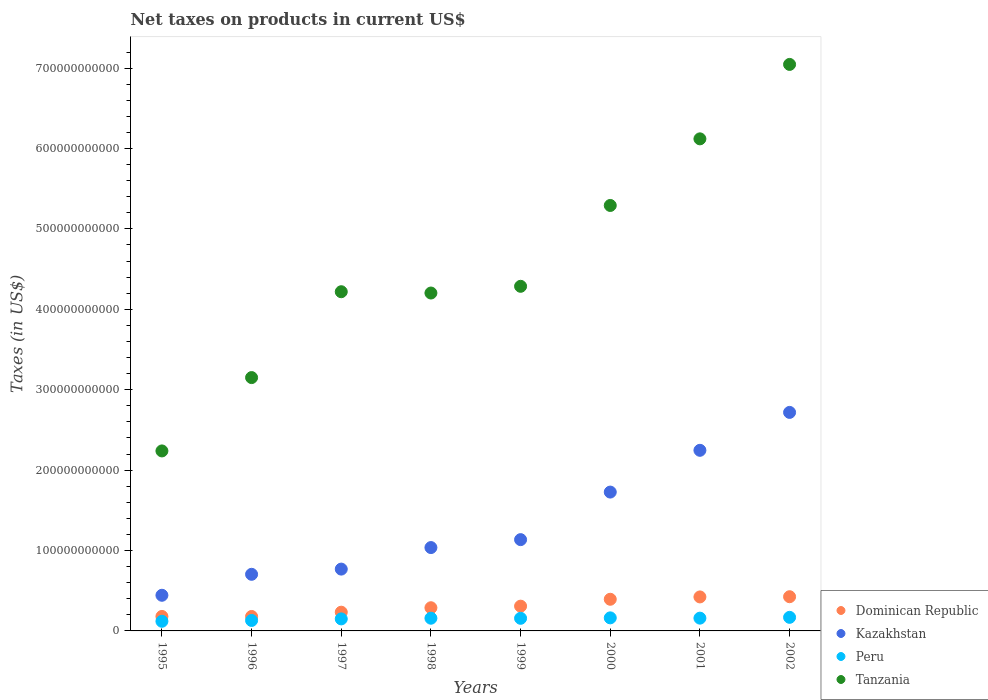Is the number of dotlines equal to the number of legend labels?
Ensure brevity in your answer.  Yes. What is the net taxes on products in Peru in 1995?
Offer a very short reply. 1.20e+1. Across all years, what is the maximum net taxes on products in Kazakhstan?
Your response must be concise. 2.72e+11. Across all years, what is the minimum net taxes on products in Tanzania?
Your response must be concise. 2.24e+11. In which year was the net taxes on products in Dominican Republic minimum?
Offer a very short reply. 1996. What is the total net taxes on products in Peru in the graph?
Offer a terse response. 1.20e+11. What is the difference between the net taxes on products in Peru in 1996 and that in 1999?
Your response must be concise. -2.68e+09. What is the difference between the net taxes on products in Peru in 1998 and the net taxes on products in Kazakhstan in 1996?
Make the answer very short. -5.46e+1. What is the average net taxes on products in Kazakhstan per year?
Your response must be concise. 1.35e+11. In the year 2002, what is the difference between the net taxes on products in Peru and net taxes on products in Dominican Republic?
Ensure brevity in your answer.  -2.57e+1. In how many years, is the net taxes on products in Peru greater than 40000000000 US$?
Offer a very short reply. 0. What is the ratio of the net taxes on products in Dominican Republic in 1995 to that in 1997?
Give a very brief answer. 0.77. What is the difference between the highest and the second highest net taxes on products in Peru?
Keep it short and to the point. 6.46e+08. What is the difference between the highest and the lowest net taxes on products in Tanzania?
Your response must be concise. 4.81e+11. Is the sum of the net taxes on products in Tanzania in 1997 and 1999 greater than the maximum net taxes on products in Kazakhstan across all years?
Keep it short and to the point. Yes. What is the difference between two consecutive major ticks on the Y-axis?
Provide a succinct answer. 1.00e+11. Does the graph contain any zero values?
Your answer should be compact. No. Does the graph contain grids?
Provide a succinct answer. No. Where does the legend appear in the graph?
Your answer should be very brief. Bottom right. How are the legend labels stacked?
Give a very brief answer. Vertical. What is the title of the graph?
Keep it short and to the point. Net taxes on products in current US$. What is the label or title of the X-axis?
Offer a very short reply. Years. What is the label or title of the Y-axis?
Offer a very short reply. Taxes (in US$). What is the Taxes (in US$) in Dominican Republic in 1995?
Give a very brief answer. 1.80e+1. What is the Taxes (in US$) of Kazakhstan in 1995?
Your answer should be very brief. 4.43e+1. What is the Taxes (in US$) of Peru in 1995?
Offer a very short reply. 1.20e+1. What is the Taxes (in US$) in Tanzania in 1995?
Offer a very short reply. 2.24e+11. What is the Taxes (in US$) of Dominican Republic in 1996?
Offer a terse response. 1.80e+1. What is the Taxes (in US$) in Kazakhstan in 1996?
Provide a succinct answer. 7.04e+1. What is the Taxes (in US$) of Peru in 1996?
Provide a succinct answer. 1.30e+1. What is the Taxes (in US$) in Tanzania in 1996?
Provide a succinct answer. 3.15e+11. What is the Taxes (in US$) of Dominican Republic in 1997?
Your answer should be very brief. 2.33e+1. What is the Taxes (in US$) in Kazakhstan in 1997?
Your answer should be compact. 7.69e+1. What is the Taxes (in US$) in Peru in 1997?
Your answer should be very brief. 1.50e+1. What is the Taxes (in US$) in Tanzania in 1997?
Offer a very short reply. 4.22e+11. What is the Taxes (in US$) of Dominican Republic in 1998?
Your answer should be compact. 2.88e+1. What is the Taxes (in US$) in Kazakhstan in 1998?
Make the answer very short. 1.04e+11. What is the Taxes (in US$) of Peru in 1998?
Give a very brief answer. 1.58e+1. What is the Taxes (in US$) in Tanzania in 1998?
Ensure brevity in your answer.  4.20e+11. What is the Taxes (in US$) in Dominican Republic in 1999?
Keep it short and to the point. 3.08e+1. What is the Taxes (in US$) of Kazakhstan in 1999?
Offer a terse response. 1.14e+11. What is the Taxes (in US$) of Peru in 1999?
Provide a succinct answer. 1.57e+1. What is the Taxes (in US$) in Tanzania in 1999?
Your answer should be very brief. 4.29e+11. What is the Taxes (in US$) of Dominican Republic in 2000?
Keep it short and to the point. 3.94e+1. What is the Taxes (in US$) of Kazakhstan in 2000?
Give a very brief answer. 1.73e+11. What is the Taxes (in US$) in Peru in 2000?
Give a very brief answer. 1.62e+1. What is the Taxes (in US$) in Tanzania in 2000?
Ensure brevity in your answer.  5.29e+11. What is the Taxes (in US$) of Dominican Republic in 2001?
Keep it short and to the point. 4.23e+1. What is the Taxes (in US$) of Kazakhstan in 2001?
Keep it short and to the point. 2.25e+11. What is the Taxes (in US$) in Peru in 2001?
Offer a terse response. 1.59e+1. What is the Taxes (in US$) in Tanzania in 2001?
Your answer should be compact. 6.12e+11. What is the Taxes (in US$) of Dominican Republic in 2002?
Offer a very short reply. 4.25e+1. What is the Taxes (in US$) in Kazakhstan in 2002?
Offer a very short reply. 2.72e+11. What is the Taxes (in US$) in Peru in 2002?
Give a very brief answer. 1.69e+1. What is the Taxes (in US$) of Tanzania in 2002?
Keep it short and to the point. 7.05e+11. Across all years, what is the maximum Taxes (in US$) of Dominican Republic?
Keep it short and to the point. 4.25e+1. Across all years, what is the maximum Taxes (in US$) of Kazakhstan?
Provide a succinct answer. 2.72e+11. Across all years, what is the maximum Taxes (in US$) of Peru?
Your answer should be very brief. 1.69e+1. Across all years, what is the maximum Taxes (in US$) in Tanzania?
Ensure brevity in your answer.  7.05e+11. Across all years, what is the minimum Taxes (in US$) of Dominican Republic?
Provide a succinct answer. 1.80e+1. Across all years, what is the minimum Taxes (in US$) of Kazakhstan?
Make the answer very short. 4.43e+1. Across all years, what is the minimum Taxes (in US$) of Peru?
Your response must be concise. 1.20e+1. Across all years, what is the minimum Taxes (in US$) of Tanzania?
Your answer should be compact. 2.24e+11. What is the total Taxes (in US$) of Dominican Republic in the graph?
Offer a terse response. 2.43e+11. What is the total Taxes (in US$) of Kazakhstan in the graph?
Your answer should be very brief. 1.08e+12. What is the total Taxes (in US$) of Peru in the graph?
Keep it short and to the point. 1.20e+11. What is the total Taxes (in US$) in Tanzania in the graph?
Your answer should be compact. 3.66e+12. What is the difference between the Taxes (in US$) of Dominican Republic in 1995 and that in 1996?
Keep it short and to the point. 4.87e+07. What is the difference between the Taxes (in US$) of Kazakhstan in 1995 and that in 1996?
Ensure brevity in your answer.  -2.61e+1. What is the difference between the Taxes (in US$) of Peru in 1995 and that in 1996?
Make the answer very short. -1.02e+09. What is the difference between the Taxes (in US$) of Tanzania in 1995 and that in 1996?
Keep it short and to the point. -9.12e+1. What is the difference between the Taxes (in US$) in Dominican Republic in 1995 and that in 1997?
Ensure brevity in your answer.  -5.27e+09. What is the difference between the Taxes (in US$) in Kazakhstan in 1995 and that in 1997?
Your response must be concise. -3.26e+1. What is the difference between the Taxes (in US$) in Peru in 1995 and that in 1997?
Your answer should be compact. -2.96e+09. What is the difference between the Taxes (in US$) of Tanzania in 1995 and that in 1997?
Provide a short and direct response. -1.98e+11. What is the difference between the Taxes (in US$) in Dominican Republic in 1995 and that in 1998?
Your answer should be compact. -1.08e+1. What is the difference between the Taxes (in US$) in Kazakhstan in 1995 and that in 1998?
Ensure brevity in your answer.  -5.93e+1. What is the difference between the Taxes (in US$) in Peru in 1995 and that in 1998?
Ensure brevity in your answer.  -3.80e+09. What is the difference between the Taxes (in US$) in Tanzania in 1995 and that in 1998?
Your answer should be very brief. -1.96e+11. What is the difference between the Taxes (in US$) of Dominican Republic in 1995 and that in 1999?
Keep it short and to the point. -1.28e+1. What is the difference between the Taxes (in US$) in Kazakhstan in 1995 and that in 1999?
Provide a short and direct response. -6.92e+1. What is the difference between the Taxes (in US$) in Peru in 1995 and that in 1999?
Give a very brief answer. -3.70e+09. What is the difference between the Taxes (in US$) of Tanzania in 1995 and that in 1999?
Your answer should be very brief. -2.05e+11. What is the difference between the Taxes (in US$) of Dominican Republic in 1995 and that in 2000?
Provide a short and direct response. -2.14e+1. What is the difference between the Taxes (in US$) of Kazakhstan in 1995 and that in 2000?
Make the answer very short. -1.28e+11. What is the difference between the Taxes (in US$) of Peru in 1995 and that in 2000?
Your answer should be compact. -4.25e+09. What is the difference between the Taxes (in US$) of Tanzania in 1995 and that in 2000?
Your answer should be compact. -3.05e+11. What is the difference between the Taxes (in US$) in Dominican Republic in 1995 and that in 2001?
Offer a terse response. -2.43e+1. What is the difference between the Taxes (in US$) of Kazakhstan in 1995 and that in 2001?
Your answer should be very brief. -1.80e+11. What is the difference between the Taxes (in US$) of Peru in 1995 and that in 2001?
Make the answer very short. -3.89e+09. What is the difference between the Taxes (in US$) of Tanzania in 1995 and that in 2001?
Offer a terse response. -3.88e+11. What is the difference between the Taxes (in US$) in Dominican Republic in 1995 and that in 2002?
Your answer should be very brief. -2.45e+1. What is the difference between the Taxes (in US$) in Kazakhstan in 1995 and that in 2002?
Ensure brevity in your answer.  -2.27e+11. What is the difference between the Taxes (in US$) of Peru in 1995 and that in 2002?
Offer a terse response. -4.89e+09. What is the difference between the Taxes (in US$) of Tanzania in 1995 and that in 2002?
Your answer should be compact. -4.81e+11. What is the difference between the Taxes (in US$) in Dominican Republic in 1996 and that in 1997?
Your answer should be compact. -5.32e+09. What is the difference between the Taxes (in US$) of Kazakhstan in 1996 and that in 1997?
Provide a succinct answer. -6.48e+09. What is the difference between the Taxes (in US$) of Peru in 1996 and that in 1997?
Your response must be concise. -1.94e+09. What is the difference between the Taxes (in US$) in Tanzania in 1996 and that in 1997?
Offer a terse response. -1.07e+11. What is the difference between the Taxes (in US$) of Dominican Republic in 1996 and that in 1998?
Your response must be concise. -1.09e+1. What is the difference between the Taxes (in US$) of Kazakhstan in 1996 and that in 1998?
Offer a terse response. -3.33e+1. What is the difference between the Taxes (in US$) in Peru in 1996 and that in 1998?
Your answer should be compact. -2.78e+09. What is the difference between the Taxes (in US$) in Tanzania in 1996 and that in 1998?
Your answer should be very brief. -1.05e+11. What is the difference between the Taxes (in US$) in Dominican Republic in 1996 and that in 1999?
Keep it short and to the point. -1.28e+1. What is the difference between the Taxes (in US$) of Kazakhstan in 1996 and that in 1999?
Offer a terse response. -4.31e+1. What is the difference between the Taxes (in US$) of Peru in 1996 and that in 1999?
Give a very brief answer. -2.68e+09. What is the difference between the Taxes (in US$) in Tanzania in 1996 and that in 1999?
Your response must be concise. -1.14e+11. What is the difference between the Taxes (in US$) in Dominican Republic in 1996 and that in 2000?
Make the answer very short. -2.14e+1. What is the difference between the Taxes (in US$) in Kazakhstan in 1996 and that in 2000?
Make the answer very short. -1.02e+11. What is the difference between the Taxes (in US$) in Peru in 1996 and that in 2000?
Ensure brevity in your answer.  -3.23e+09. What is the difference between the Taxes (in US$) in Tanzania in 1996 and that in 2000?
Provide a short and direct response. -2.14e+11. What is the difference between the Taxes (in US$) of Dominican Republic in 1996 and that in 2001?
Offer a terse response. -2.43e+1. What is the difference between the Taxes (in US$) of Kazakhstan in 1996 and that in 2001?
Provide a succinct answer. -1.54e+11. What is the difference between the Taxes (in US$) in Peru in 1996 and that in 2001?
Your answer should be compact. -2.87e+09. What is the difference between the Taxes (in US$) in Tanzania in 1996 and that in 2001?
Offer a terse response. -2.97e+11. What is the difference between the Taxes (in US$) in Dominican Republic in 1996 and that in 2002?
Ensure brevity in your answer.  -2.46e+1. What is the difference between the Taxes (in US$) of Kazakhstan in 1996 and that in 2002?
Make the answer very short. -2.01e+11. What is the difference between the Taxes (in US$) in Peru in 1996 and that in 2002?
Offer a terse response. -3.87e+09. What is the difference between the Taxes (in US$) in Tanzania in 1996 and that in 2002?
Keep it short and to the point. -3.89e+11. What is the difference between the Taxes (in US$) in Dominican Republic in 1997 and that in 1998?
Keep it short and to the point. -5.54e+09. What is the difference between the Taxes (in US$) of Kazakhstan in 1997 and that in 1998?
Your answer should be compact. -2.68e+1. What is the difference between the Taxes (in US$) of Peru in 1997 and that in 1998?
Your answer should be very brief. -8.38e+08. What is the difference between the Taxes (in US$) of Tanzania in 1997 and that in 1998?
Give a very brief answer. 1.62e+09. What is the difference between the Taxes (in US$) in Dominican Republic in 1997 and that in 1999?
Your answer should be compact. -7.51e+09. What is the difference between the Taxes (in US$) in Kazakhstan in 1997 and that in 1999?
Your answer should be very brief. -3.66e+1. What is the difference between the Taxes (in US$) in Peru in 1997 and that in 1999?
Your answer should be compact. -7.37e+08. What is the difference between the Taxes (in US$) in Tanzania in 1997 and that in 1999?
Provide a short and direct response. -6.75e+09. What is the difference between the Taxes (in US$) of Dominican Republic in 1997 and that in 2000?
Offer a terse response. -1.61e+1. What is the difference between the Taxes (in US$) in Kazakhstan in 1997 and that in 2000?
Your response must be concise. -9.58e+1. What is the difference between the Taxes (in US$) of Peru in 1997 and that in 2000?
Make the answer very short. -1.28e+09. What is the difference between the Taxes (in US$) of Tanzania in 1997 and that in 2000?
Ensure brevity in your answer.  -1.07e+11. What is the difference between the Taxes (in US$) of Dominican Republic in 1997 and that in 2001?
Keep it short and to the point. -1.90e+1. What is the difference between the Taxes (in US$) in Kazakhstan in 1997 and that in 2001?
Offer a terse response. -1.48e+11. What is the difference between the Taxes (in US$) of Peru in 1997 and that in 2001?
Keep it short and to the point. -9.29e+08. What is the difference between the Taxes (in US$) of Tanzania in 1997 and that in 2001?
Keep it short and to the point. -1.90e+11. What is the difference between the Taxes (in US$) in Dominican Republic in 1997 and that in 2002?
Make the answer very short. -1.93e+1. What is the difference between the Taxes (in US$) in Kazakhstan in 1997 and that in 2002?
Your response must be concise. -1.95e+11. What is the difference between the Taxes (in US$) in Peru in 1997 and that in 2002?
Make the answer very short. -1.93e+09. What is the difference between the Taxes (in US$) of Tanzania in 1997 and that in 2002?
Your answer should be very brief. -2.83e+11. What is the difference between the Taxes (in US$) of Dominican Republic in 1998 and that in 1999?
Offer a terse response. -1.97e+09. What is the difference between the Taxes (in US$) of Kazakhstan in 1998 and that in 1999?
Your response must be concise. -9.86e+09. What is the difference between the Taxes (in US$) in Peru in 1998 and that in 1999?
Give a very brief answer. 1.01e+08. What is the difference between the Taxes (in US$) in Tanzania in 1998 and that in 1999?
Provide a short and direct response. -8.36e+09. What is the difference between the Taxes (in US$) in Dominican Republic in 1998 and that in 2000?
Your response must be concise. -1.05e+1. What is the difference between the Taxes (in US$) of Kazakhstan in 1998 and that in 2000?
Keep it short and to the point. -6.90e+1. What is the difference between the Taxes (in US$) of Peru in 1998 and that in 2000?
Your response must be concise. -4.46e+08. What is the difference between the Taxes (in US$) of Tanzania in 1998 and that in 2000?
Provide a succinct answer. -1.09e+11. What is the difference between the Taxes (in US$) in Dominican Republic in 1998 and that in 2001?
Ensure brevity in your answer.  -1.35e+1. What is the difference between the Taxes (in US$) in Kazakhstan in 1998 and that in 2001?
Your answer should be compact. -1.21e+11. What is the difference between the Taxes (in US$) in Peru in 1998 and that in 2001?
Make the answer very short. -9.18e+07. What is the difference between the Taxes (in US$) in Tanzania in 1998 and that in 2001?
Give a very brief answer. -1.92e+11. What is the difference between the Taxes (in US$) of Dominican Republic in 1998 and that in 2002?
Your response must be concise. -1.37e+1. What is the difference between the Taxes (in US$) of Kazakhstan in 1998 and that in 2002?
Your answer should be compact. -1.68e+11. What is the difference between the Taxes (in US$) of Peru in 1998 and that in 2002?
Give a very brief answer. -1.09e+09. What is the difference between the Taxes (in US$) of Tanzania in 1998 and that in 2002?
Keep it short and to the point. -2.84e+11. What is the difference between the Taxes (in US$) of Dominican Republic in 1999 and that in 2000?
Your response must be concise. -8.57e+09. What is the difference between the Taxes (in US$) of Kazakhstan in 1999 and that in 2000?
Your response must be concise. -5.92e+1. What is the difference between the Taxes (in US$) of Peru in 1999 and that in 2000?
Give a very brief answer. -5.47e+08. What is the difference between the Taxes (in US$) in Tanzania in 1999 and that in 2000?
Provide a short and direct response. -1.01e+11. What is the difference between the Taxes (in US$) in Dominican Republic in 1999 and that in 2001?
Your answer should be compact. -1.15e+1. What is the difference between the Taxes (in US$) in Kazakhstan in 1999 and that in 2001?
Provide a succinct answer. -1.11e+11. What is the difference between the Taxes (in US$) of Peru in 1999 and that in 2001?
Offer a very short reply. -1.93e+08. What is the difference between the Taxes (in US$) of Tanzania in 1999 and that in 2001?
Keep it short and to the point. -1.83e+11. What is the difference between the Taxes (in US$) of Dominican Republic in 1999 and that in 2002?
Give a very brief answer. -1.17e+1. What is the difference between the Taxes (in US$) of Kazakhstan in 1999 and that in 2002?
Ensure brevity in your answer.  -1.58e+11. What is the difference between the Taxes (in US$) in Peru in 1999 and that in 2002?
Ensure brevity in your answer.  -1.19e+09. What is the difference between the Taxes (in US$) of Tanzania in 1999 and that in 2002?
Your response must be concise. -2.76e+11. What is the difference between the Taxes (in US$) in Dominican Republic in 2000 and that in 2001?
Your response must be concise. -2.92e+09. What is the difference between the Taxes (in US$) of Kazakhstan in 2000 and that in 2001?
Give a very brief answer. -5.19e+1. What is the difference between the Taxes (in US$) of Peru in 2000 and that in 2001?
Your answer should be compact. 3.54e+08. What is the difference between the Taxes (in US$) of Tanzania in 2000 and that in 2001?
Provide a short and direct response. -8.28e+1. What is the difference between the Taxes (in US$) of Dominican Republic in 2000 and that in 2002?
Your response must be concise. -3.17e+09. What is the difference between the Taxes (in US$) in Kazakhstan in 2000 and that in 2002?
Keep it short and to the point. -9.91e+1. What is the difference between the Taxes (in US$) in Peru in 2000 and that in 2002?
Your response must be concise. -6.46e+08. What is the difference between the Taxes (in US$) of Tanzania in 2000 and that in 2002?
Keep it short and to the point. -1.75e+11. What is the difference between the Taxes (in US$) of Dominican Republic in 2001 and that in 2002?
Make the answer very short. -2.54e+08. What is the difference between the Taxes (in US$) of Kazakhstan in 2001 and that in 2002?
Your response must be concise. -4.72e+1. What is the difference between the Taxes (in US$) of Peru in 2001 and that in 2002?
Make the answer very short. -1.00e+09. What is the difference between the Taxes (in US$) in Tanzania in 2001 and that in 2002?
Keep it short and to the point. -9.26e+1. What is the difference between the Taxes (in US$) of Dominican Republic in 1995 and the Taxes (in US$) of Kazakhstan in 1996?
Provide a short and direct response. -5.24e+1. What is the difference between the Taxes (in US$) of Dominican Republic in 1995 and the Taxes (in US$) of Peru in 1996?
Provide a succinct answer. 5.00e+09. What is the difference between the Taxes (in US$) of Dominican Republic in 1995 and the Taxes (in US$) of Tanzania in 1996?
Give a very brief answer. -2.97e+11. What is the difference between the Taxes (in US$) in Kazakhstan in 1995 and the Taxes (in US$) in Peru in 1996?
Provide a short and direct response. 3.13e+1. What is the difference between the Taxes (in US$) in Kazakhstan in 1995 and the Taxes (in US$) in Tanzania in 1996?
Keep it short and to the point. -2.71e+11. What is the difference between the Taxes (in US$) of Peru in 1995 and the Taxes (in US$) of Tanzania in 1996?
Provide a short and direct response. -3.03e+11. What is the difference between the Taxes (in US$) of Dominican Republic in 1995 and the Taxes (in US$) of Kazakhstan in 1997?
Provide a short and direct response. -5.89e+1. What is the difference between the Taxes (in US$) of Dominican Republic in 1995 and the Taxes (in US$) of Peru in 1997?
Your response must be concise. 3.06e+09. What is the difference between the Taxes (in US$) in Dominican Republic in 1995 and the Taxes (in US$) in Tanzania in 1997?
Give a very brief answer. -4.04e+11. What is the difference between the Taxes (in US$) in Kazakhstan in 1995 and the Taxes (in US$) in Peru in 1997?
Provide a succinct answer. 2.94e+1. What is the difference between the Taxes (in US$) in Kazakhstan in 1995 and the Taxes (in US$) in Tanzania in 1997?
Your response must be concise. -3.78e+11. What is the difference between the Taxes (in US$) in Peru in 1995 and the Taxes (in US$) in Tanzania in 1997?
Keep it short and to the point. -4.10e+11. What is the difference between the Taxes (in US$) of Dominican Republic in 1995 and the Taxes (in US$) of Kazakhstan in 1998?
Offer a very short reply. -8.57e+1. What is the difference between the Taxes (in US$) in Dominican Republic in 1995 and the Taxes (in US$) in Peru in 1998?
Offer a terse response. 2.22e+09. What is the difference between the Taxes (in US$) in Dominican Republic in 1995 and the Taxes (in US$) in Tanzania in 1998?
Your answer should be compact. -4.02e+11. What is the difference between the Taxes (in US$) of Kazakhstan in 1995 and the Taxes (in US$) of Peru in 1998?
Make the answer very short. 2.85e+1. What is the difference between the Taxes (in US$) of Kazakhstan in 1995 and the Taxes (in US$) of Tanzania in 1998?
Give a very brief answer. -3.76e+11. What is the difference between the Taxes (in US$) in Peru in 1995 and the Taxes (in US$) in Tanzania in 1998?
Provide a short and direct response. -4.08e+11. What is the difference between the Taxes (in US$) in Dominican Republic in 1995 and the Taxes (in US$) in Kazakhstan in 1999?
Give a very brief answer. -9.55e+1. What is the difference between the Taxes (in US$) in Dominican Republic in 1995 and the Taxes (in US$) in Peru in 1999?
Your answer should be compact. 2.32e+09. What is the difference between the Taxes (in US$) of Dominican Republic in 1995 and the Taxes (in US$) of Tanzania in 1999?
Make the answer very short. -4.11e+11. What is the difference between the Taxes (in US$) in Kazakhstan in 1995 and the Taxes (in US$) in Peru in 1999?
Make the answer very short. 2.86e+1. What is the difference between the Taxes (in US$) in Kazakhstan in 1995 and the Taxes (in US$) in Tanzania in 1999?
Give a very brief answer. -3.84e+11. What is the difference between the Taxes (in US$) of Peru in 1995 and the Taxes (in US$) of Tanzania in 1999?
Your answer should be very brief. -4.17e+11. What is the difference between the Taxes (in US$) in Dominican Republic in 1995 and the Taxes (in US$) in Kazakhstan in 2000?
Your answer should be compact. -1.55e+11. What is the difference between the Taxes (in US$) of Dominican Republic in 1995 and the Taxes (in US$) of Peru in 2000?
Ensure brevity in your answer.  1.78e+09. What is the difference between the Taxes (in US$) of Dominican Republic in 1995 and the Taxes (in US$) of Tanzania in 2000?
Your response must be concise. -5.11e+11. What is the difference between the Taxes (in US$) of Kazakhstan in 1995 and the Taxes (in US$) of Peru in 2000?
Give a very brief answer. 2.81e+1. What is the difference between the Taxes (in US$) in Kazakhstan in 1995 and the Taxes (in US$) in Tanzania in 2000?
Your answer should be very brief. -4.85e+11. What is the difference between the Taxes (in US$) of Peru in 1995 and the Taxes (in US$) of Tanzania in 2000?
Offer a terse response. -5.17e+11. What is the difference between the Taxes (in US$) of Dominican Republic in 1995 and the Taxes (in US$) of Kazakhstan in 2001?
Keep it short and to the point. -2.07e+11. What is the difference between the Taxes (in US$) of Dominican Republic in 1995 and the Taxes (in US$) of Peru in 2001?
Offer a very short reply. 2.13e+09. What is the difference between the Taxes (in US$) of Dominican Republic in 1995 and the Taxes (in US$) of Tanzania in 2001?
Your response must be concise. -5.94e+11. What is the difference between the Taxes (in US$) of Kazakhstan in 1995 and the Taxes (in US$) of Peru in 2001?
Your response must be concise. 2.84e+1. What is the difference between the Taxes (in US$) in Kazakhstan in 1995 and the Taxes (in US$) in Tanzania in 2001?
Provide a succinct answer. -5.68e+11. What is the difference between the Taxes (in US$) of Peru in 1995 and the Taxes (in US$) of Tanzania in 2001?
Offer a terse response. -6.00e+11. What is the difference between the Taxes (in US$) of Dominican Republic in 1995 and the Taxes (in US$) of Kazakhstan in 2002?
Offer a very short reply. -2.54e+11. What is the difference between the Taxes (in US$) in Dominican Republic in 1995 and the Taxes (in US$) in Peru in 2002?
Your answer should be very brief. 1.13e+09. What is the difference between the Taxes (in US$) in Dominican Republic in 1995 and the Taxes (in US$) in Tanzania in 2002?
Give a very brief answer. -6.87e+11. What is the difference between the Taxes (in US$) of Kazakhstan in 1995 and the Taxes (in US$) of Peru in 2002?
Give a very brief answer. 2.74e+1. What is the difference between the Taxes (in US$) in Kazakhstan in 1995 and the Taxes (in US$) in Tanzania in 2002?
Ensure brevity in your answer.  -6.60e+11. What is the difference between the Taxes (in US$) of Peru in 1995 and the Taxes (in US$) of Tanzania in 2002?
Ensure brevity in your answer.  -6.93e+11. What is the difference between the Taxes (in US$) in Dominican Republic in 1996 and the Taxes (in US$) in Kazakhstan in 1997?
Give a very brief answer. -5.89e+1. What is the difference between the Taxes (in US$) in Dominican Republic in 1996 and the Taxes (in US$) in Peru in 1997?
Your response must be concise. 3.01e+09. What is the difference between the Taxes (in US$) of Dominican Republic in 1996 and the Taxes (in US$) of Tanzania in 1997?
Your response must be concise. -4.04e+11. What is the difference between the Taxes (in US$) in Kazakhstan in 1996 and the Taxes (in US$) in Peru in 1997?
Provide a short and direct response. 5.55e+1. What is the difference between the Taxes (in US$) in Kazakhstan in 1996 and the Taxes (in US$) in Tanzania in 1997?
Provide a succinct answer. -3.51e+11. What is the difference between the Taxes (in US$) in Peru in 1996 and the Taxes (in US$) in Tanzania in 1997?
Provide a short and direct response. -4.09e+11. What is the difference between the Taxes (in US$) in Dominican Republic in 1996 and the Taxes (in US$) in Kazakhstan in 1998?
Your answer should be compact. -8.57e+1. What is the difference between the Taxes (in US$) of Dominican Republic in 1996 and the Taxes (in US$) of Peru in 1998?
Keep it short and to the point. 2.17e+09. What is the difference between the Taxes (in US$) in Dominican Republic in 1996 and the Taxes (in US$) in Tanzania in 1998?
Make the answer very short. -4.02e+11. What is the difference between the Taxes (in US$) in Kazakhstan in 1996 and the Taxes (in US$) in Peru in 1998?
Ensure brevity in your answer.  5.46e+1. What is the difference between the Taxes (in US$) of Kazakhstan in 1996 and the Taxes (in US$) of Tanzania in 1998?
Keep it short and to the point. -3.50e+11. What is the difference between the Taxes (in US$) of Peru in 1996 and the Taxes (in US$) of Tanzania in 1998?
Make the answer very short. -4.07e+11. What is the difference between the Taxes (in US$) in Dominican Republic in 1996 and the Taxes (in US$) in Kazakhstan in 1999?
Offer a terse response. -9.56e+1. What is the difference between the Taxes (in US$) of Dominican Republic in 1996 and the Taxes (in US$) of Peru in 1999?
Provide a short and direct response. 2.27e+09. What is the difference between the Taxes (in US$) of Dominican Republic in 1996 and the Taxes (in US$) of Tanzania in 1999?
Offer a terse response. -4.11e+11. What is the difference between the Taxes (in US$) in Kazakhstan in 1996 and the Taxes (in US$) in Peru in 1999?
Give a very brief answer. 5.47e+1. What is the difference between the Taxes (in US$) in Kazakhstan in 1996 and the Taxes (in US$) in Tanzania in 1999?
Make the answer very short. -3.58e+11. What is the difference between the Taxes (in US$) in Peru in 1996 and the Taxes (in US$) in Tanzania in 1999?
Provide a short and direct response. -4.16e+11. What is the difference between the Taxes (in US$) in Dominican Republic in 1996 and the Taxes (in US$) in Kazakhstan in 2000?
Give a very brief answer. -1.55e+11. What is the difference between the Taxes (in US$) of Dominican Republic in 1996 and the Taxes (in US$) of Peru in 2000?
Offer a terse response. 1.73e+09. What is the difference between the Taxes (in US$) of Dominican Republic in 1996 and the Taxes (in US$) of Tanzania in 2000?
Provide a succinct answer. -5.11e+11. What is the difference between the Taxes (in US$) in Kazakhstan in 1996 and the Taxes (in US$) in Peru in 2000?
Offer a terse response. 5.42e+1. What is the difference between the Taxes (in US$) in Kazakhstan in 1996 and the Taxes (in US$) in Tanzania in 2000?
Offer a terse response. -4.59e+11. What is the difference between the Taxes (in US$) of Peru in 1996 and the Taxes (in US$) of Tanzania in 2000?
Ensure brevity in your answer.  -5.16e+11. What is the difference between the Taxes (in US$) of Dominican Republic in 1996 and the Taxes (in US$) of Kazakhstan in 2001?
Your answer should be very brief. -2.07e+11. What is the difference between the Taxes (in US$) of Dominican Republic in 1996 and the Taxes (in US$) of Peru in 2001?
Provide a short and direct response. 2.08e+09. What is the difference between the Taxes (in US$) in Dominican Republic in 1996 and the Taxes (in US$) in Tanzania in 2001?
Offer a very short reply. -5.94e+11. What is the difference between the Taxes (in US$) of Kazakhstan in 1996 and the Taxes (in US$) of Peru in 2001?
Give a very brief answer. 5.45e+1. What is the difference between the Taxes (in US$) in Kazakhstan in 1996 and the Taxes (in US$) in Tanzania in 2001?
Make the answer very short. -5.42e+11. What is the difference between the Taxes (in US$) of Peru in 1996 and the Taxes (in US$) of Tanzania in 2001?
Keep it short and to the point. -5.99e+11. What is the difference between the Taxes (in US$) of Dominican Republic in 1996 and the Taxes (in US$) of Kazakhstan in 2002?
Make the answer very short. -2.54e+11. What is the difference between the Taxes (in US$) of Dominican Republic in 1996 and the Taxes (in US$) of Peru in 2002?
Your answer should be compact. 1.08e+09. What is the difference between the Taxes (in US$) of Dominican Republic in 1996 and the Taxes (in US$) of Tanzania in 2002?
Give a very brief answer. -6.87e+11. What is the difference between the Taxes (in US$) of Kazakhstan in 1996 and the Taxes (in US$) of Peru in 2002?
Keep it short and to the point. 5.35e+1. What is the difference between the Taxes (in US$) of Kazakhstan in 1996 and the Taxes (in US$) of Tanzania in 2002?
Offer a terse response. -6.34e+11. What is the difference between the Taxes (in US$) of Peru in 1996 and the Taxes (in US$) of Tanzania in 2002?
Your answer should be compact. -6.92e+11. What is the difference between the Taxes (in US$) of Dominican Republic in 1997 and the Taxes (in US$) of Kazakhstan in 1998?
Provide a short and direct response. -8.04e+1. What is the difference between the Taxes (in US$) in Dominican Republic in 1997 and the Taxes (in US$) in Peru in 1998?
Your response must be concise. 7.49e+09. What is the difference between the Taxes (in US$) of Dominican Republic in 1997 and the Taxes (in US$) of Tanzania in 1998?
Keep it short and to the point. -3.97e+11. What is the difference between the Taxes (in US$) of Kazakhstan in 1997 and the Taxes (in US$) of Peru in 1998?
Make the answer very short. 6.11e+1. What is the difference between the Taxes (in US$) of Kazakhstan in 1997 and the Taxes (in US$) of Tanzania in 1998?
Give a very brief answer. -3.43e+11. What is the difference between the Taxes (in US$) of Peru in 1997 and the Taxes (in US$) of Tanzania in 1998?
Your response must be concise. -4.05e+11. What is the difference between the Taxes (in US$) in Dominican Republic in 1997 and the Taxes (in US$) in Kazakhstan in 1999?
Provide a succinct answer. -9.02e+1. What is the difference between the Taxes (in US$) in Dominican Republic in 1997 and the Taxes (in US$) in Peru in 1999?
Keep it short and to the point. 7.59e+09. What is the difference between the Taxes (in US$) in Dominican Republic in 1997 and the Taxes (in US$) in Tanzania in 1999?
Provide a short and direct response. -4.05e+11. What is the difference between the Taxes (in US$) of Kazakhstan in 1997 and the Taxes (in US$) of Peru in 1999?
Offer a terse response. 6.12e+1. What is the difference between the Taxes (in US$) of Kazakhstan in 1997 and the Taxes (in US$) of Tanzania in 1999?
Ensure brevity in your answer.  -3.52e+11. What is the difference between the Taxes (in US$) in Peru in 1997 and the Taxes (in US$) in Tanzania in 1999?
Make the answer very short. -4.14e+11. What is the difference between the Taxes (in US$) of Dominican Republic in 1997 and the Taxes (in US$) of Kazakhstan in 2000?
Your answer should be very brief. -1.49e+11. What is the difference between the Taxes (in US$) of Dominican Republic in 1997 and the Taxes (in US$) of Peru in 2000?
Keep it short and to the point. 7.05e+09. What is the difference between the Taxes (in US$) in Dominican Republic in 1997 and the Taxes (in US$) in Tanzania in 2000?
Offer a very short reply. -5.06e+11. What is the difference between the Taxes (in US$) of Kazakhstan in 1997 and the Taxes (in US$) of Peru in 2000?
Ensure brevity in your answer.  6.06e+1. What is the difference between the Taxes (in US$) in Kazakhstan in 1997 and the Taxes (in US$) in Tanzania in 2000?
Your answer should be compact. -4.52e+11. What is the difference between the Taxes (in US$) in Peru in 1997 and the Taxes (in US$) in Tanzania in 2000?
Ensure brevity in your answer.  -5.14e+11. What is the difference between the Taxes (in US$) in Dominican Republic in 1997 and the Taxes (in US$) in Kazakhstan in 2001?
Offer a very short reply. -2.01e+11. What is the difference between the Taxes (in US$) in Dominican Republic in 1997 and the Taxes (in US$) in Peru in 2001?
Your answer should be compact. 7.40e+09. What is the difference between the Taxes (in US$) in Dominican Republic in 1997 and the Taxes (in US$) in Tanzania in 2001?
Offer a very short reply. -5.89e+11. What is the difference between the Taxes (in US$) of Kazakhstan in 1997 and the Taxes (in US$) of Peru in 2001?
Your answer should be very brief. 6.10e+1. What is the difference between the Taxes (in US$) in Kazakhstan in 1997 and the Taxes (in US$) in Tanzania in 2001?
Ensure brevity in your answer.  -5.35e+11. What is the difference between the Taxes (in US$) of Peru in 1997 and the Taxes (in US$) of Tanzania in 2001?
Offer a very short reply. -5.97e+11. What is the difference between the Taxes (in US$) in Dominican Republic in 1997 and the Taxes (in US$) in Kazakhstan in 2002?
Your answer should be compact. -2.48e+11. What is the difference between the Taxes (in US$) in Dominican Republic in 1997 and the Taxes (in US$) in Peru in 2002?
Your answer should be compact. 6.40e+09. What is the difference between the Taxes (in US$) of Dominican Republic in 1997 and the Taxes (in US$) of Tanzania in 2002?
Your answer should be very brief. -6.81e+11. What is the difference between the Taxes (in US$) of Kazakhstan in 1997 and the Taxes (in US$) of Peru in 2002?
Your response must be concise. 6.00e+1. What is the difference between the Taxes (in US$) in Kazakhstan in 1997 and the Taxes (in US$) in Tanzania in 2002?
Make the answer very short. -6.28e+11. What is the difference between the Taxes (in US$) of Peru in 1997 and the Taxes (in US$) of Tanzania in 2002?
Make the answer very short. -6.90e+11. What is the difference between the Taxes (in US$) in Dominican Republic in 1998 and the Taxes (in US$) in Kazakhstan in 1999?
Your answer should be compact. -8.47e+1. What is the difference between the Taxes (in US$) of Dominican Republic in 1998 and the Taxes (in US$) of Peru in 1999?
Offer a very short reply. 1.31e+1. What is the difference between the Taxes (in US$) of Dominican Republic in 1998 and the Taxes (in US$) of Tanzania in 1999?
Make the answer very short. -4.00e+11. What is the difference between the Taxes (in US$) in Kazakhstan in 1998 and the Taxes (in US$) in Peru in 1999?
Your response must be concise. 8.80e+1. What is the difference between the Taxes (in US$) in Kazakhstan in 1998 and the Taxes (in US$) in Tanzania in 1999?
Keep it short and to the point. -3.25e+11. What is the difference between the Taxes (in US$) in Peru in 1998 and the Taxes (in US$) in Tanzania in 1999?
Offer a very short reply. -4.13e+11. What is the difference between the Taxes (in US$) of Dominican Republic in 1998 and the Taxes (in US$) of Kazakhstan in 2000?
Your answer should be very brief. -1.44e+11. What is the difference between the Taxes (in US$) of Dominican Republic in 1998 and the Taxes (in US$) of Peru in 2000?
Offer a very short reply. 1.26e+1. What is the difference between the Taxes (in US$) of Dominican Republic in 1998 and the Taxes (in US$) of Tanzania in 2000?
Make the answer very short. -5.00e+11. What is the difference between the Taxes (in US$) of Kazakhstan in 1998 and the Taxes (in US$) of Peru in 2000?
Provide a short and direct response. 8.74e+1. What is the difference between the Taxes (in US$) in Kazakhstan in 1998 and the Taxes (in US$) in Tanzania in 2000?
Provide a short and direct response. -4.25e+11. What is the difference between the Taxes (in US$) in Peru in 1998 and the Taxes (in US$) in Tanzania in 2000?
Your answer should be very brief. -5.13e+11. What is the difference between the Taxes (in US$) in Dominican Republic in 1998 and the Taxes (in US$) in Kazakhstan in 2001?
Provide a succinct answer. -1.96e+11. What is the difference between the Taxes (in US$) in Dominican Republic in 1998 and the Taxes (in US$) in Peru in 2001?
Offer a terse response. 1.29e+1. What is the difference between the Taxes (in US$) of Dominican Republic in 1998 and the Taxes (in US$) of Tanzania in 2001?
Ensure brevity in your answer.  -5.83e+11. What is the difference between the Taxes (in US$) of Kazakhstan in 1998 and the Taxes (in US$) of Peru in 2001?
Provide a short and direct response. 8.78e+1. What is the difference between the Taxes (in US$) in Kazakhstan in 1998 and the Taxes (in US$) in Tanzania in 2001?
Offer a terse response. -5.08e+11. What is the difference between the Taxes (in US$) in Peru in 1998 and the Taxes (in US$) in Tanzania in 2001?
Offer a terse response. -5.96e+11. What is the difference between the Taxes (in US$) of Dominican Republic in 1998 and the Taxes (in US$) of Kazakhstan in 2002?
Your response must be concise. -2.43e+11. What is the difference between the Taxes (in US$) of Dominican Republic in 1998 and the Taxes (in US$) of Peru in 2002?
Your answer should be compact. 1.19e+1. What is the difference between the Taxes (in US$) in Dominican Republic in 1998 and the Taxes (in US$) in Tanzania in 2002?
Offer a terse response. -6.76e+11. What is the difference between the Taxes (in US$) in Kazakhstan in 1998 and the Taxes (in US$) in Peru in 2002?
Give a very brief answer. 8.68e+1. What is the difference between the Taxes (in US$) in Kazakhstan in 1998 and the Taxes (in US$) in Tanzania in 2002?
Ensure brevity in your answer.  -6.01e+11. What is the difference between the Taxes (in US$) in Peru in 1998 and the Taxes (in US$) in Tanzania in 2002?
Give a very brief answer. -6.89e+11. What is the difference between the Taxes (in US$) in Dominican Republic in 1999 and the Taxes (in US$) in Kazakhstan in 2000?
Your answer should be compact. -1.42e+11. What is the difference between the Taxes (in US$) in Dominican Republic in 1999 and the Taxes (in US$) in Peru in 2000?
Offer a very short reply. 1.46e+1. What is the difference between the Taxes (in US$) in Dominican Republic in 1999 and the Taxes (in US$) in Tanzania in 2000?
Offer a very short reply. -4.98e+11. What is the difference between the Taxes (in US$) of Kazakhstan in 1999 and the Taxes (in US$) of Peru in 2000?
Make the answer very short. 9.73e+1. What is the difference between the Taxes (in US$) of Kazakhstan in 1999 and the Taxes (in US$) of Tanzania in 2000?
Make the answer very short. -4.16e+11. What is the difference between the Taxes (in US$) of Peru in 1999 and the Taxes (in US$) of Tanzania in 2000?
Your answer should be compact. -5.13e+11. What is the difference between the Taxes (in US$) of Dominican Republic in 1999 and the Taxes (in US$) of Kazakhstan in 2001?
Your answer should be very brief. -1.94e+11. What is the difference between the Taxes (in US$) of Dominican Republic in 1999 and the Taxes (in US$) of Peru in 2001?
Your response must be concise. 1.49e+1. What is the difference between the Taxes (in US$) of Dominican Republic in 1999 and the Taxes (in US$) of Tanzania in 2001?
Your answer should be compact. -5.81e+11. What is the difference between the Taxes (in US$) of Kazakhstan in 1999 and the Taxes (in US$) of Peru in 2001?
Keep it short and to the point. 9.76e+1. What is the difference between the Taxes (in US$) of Kazakhstan in 1999 and the Taxes (in US$) of Tanzania in 2001?
Keep it short and to the point. -4.98e+11. What is the difference between the Taxes (in US$) of Peru in 1999 and the Taxes (in US$) of Tanzania in 2001?
Ensure brevity in your answer.  -5.96e+11. What is the difference between the Taxes (in US$) in Dominican Republic in 1999 and the Taxes (in US$) in Kazakhstan in 2002?
Provide a succinct answer. -2.41e+11. What is the difference between the Taxes (in US$) in Dominican Republic in 1999 and the Taxes (in US$) in Peru in 2002?
Offer a very short reply. 1.39e+1. What is the difference between the Taxes (in US$) of Dominican Republic in 1999 and the Taxes (in US$) of Tanzania in 2002?
Your response must be concise. -6.74e+11. What is the difference between the Taxes (in US$) of Kazakhstan in 1999 and the Taxes (in US$) of Peru in 2002?
Provide a succinct answer. 9.66e+1. What is the difference between the Taxes (in US$) in Kazakhstan in 1999 and the Taxes (in US$) in Tanzania in 2002?
Provide a succinct answer. -5.91e+11. What is the difference between the Taxes (in US$) of Peru in 1999 and the Taxes (in US$) of Tanzania in 2002?
Your answer should be compact. -6.89e+11. What is the difference between the Taxes (in US$) in Dominican Republic in 2000 and the Taxes (in US$) in Kazakhstan in 2001?
Ensure brevity in your answer.  -1.85e+11. What is the difference between the Taxes (in US$) of Dominican Republic in 2000 and the Taxes (in US$) of Peru in 2001?
Ensure brevity in your answer.  2.35e+1. What is the difference between the Taxes (in US$) of Dominican Republic in 2000 and the Taxes (in US$) of Tanzania in 2001?
Keep it short and to the point. -5.73e+11. What is the difference between the Taxes (in US$) in Kazakhstan in 2000 and the Taxes (in US$) in Peru in 2001?
Keep it short and to the point. 1.57e+11. What is the difference between the Taxes (in US$) in Kazakhstan in 2000 and the Taxes (in US$) in Tanzania in 2001?
Provide a succinct answer. -4.39e+11. What is the difference between the Taxes (in US$) in Peru in 2000 and the Taxes (in US$) in Tanzania in 2001?
Give a very brief answer. -5.96e+11. What is the difference between the Taxes (in US$) of Dominican Republic in 2000 and the Taxes (in US$) of Kazakhstan in 2002?
Your answer should be very brief. -2.32e+11. What is the difference between the Taxes (in US$) of Dominican Republic in 2000 and the Taxes (in US$) of Peru in 2002?
Your response must be concise. 2.25e+1. What is the difference between the Taxes (in US$) in Dominican Republic in 2000 and the Taxes (in US$) in Tanzania in 2002?
Your answer should be compact. -6.65e+11. What is the difference between the Taxes (in US$) of Kazakhstan in 2000 and the Taxes (in US$) of Peru in 2002?
Keep it short and to the point. 1.56e+11. What is the difference between the Taxes (in US$) of Kazakhstan in 2000 and the Taxes (in US$) of Tanzania in 2002?
Give a very brief answer. -5.32e+11. What is the difference between the Taxes (in US$) of Peru in 2000 and the Taxes (in US$) of Tanzania in 2002?
Offer a terse response. -6.88e+11. What is the difference between the Taxes (in US$) of Dominican Republic in 2001 and the Taxes (in US$) of Kazakhstan in 2002?
Keep it short and to the point. -2.29e+11. What is the difference between the Taxes (in US$) in Dominican Republic in 2001 and the Taxes (in US$) in Peru in 2002?
Provide a succinct answer. 2.54e+1. What is the difference between the Taxes (in US$) of Dominican Republic in 2001 and the Taxes (in US$) of Tanzania in 2002?
Your answer should be compact. -6.62e+11. What is the difference between the Taxes (in US$) in Kazakhstan in 2001 and the Taxes (in US$) in Peru in 2002?
Your response must be concise. 2.08e+11. What is the difference between the Taxes (in US$) in Kazakhstan in 2001 and the Taxes (in US$) in Tanzania in 2002?
Offer a very short reply. -4.80e+11. What is the difference between the Taxes (in US$) of Peru in 2001 and the Taxes (in US$) of Tanzania in 2002?
Offer a very short reply. -6.89e+11. What is the average Taxes (in US$) of Dominican Republic per year?
Your answer should be compact. 3.04e+1. What is the average Taxes (in US$) of Kazakhstan per year?
Give a very brief answer. 1.35e+11. What is the average Taxes (in US$) of Peru per year?
Your response must be concise. 1.51e+1. What is the average Taxes (in US$) in Tanzania per year?
Offer a terse response. 4.57e+11. In the year 1995, what is the difference between the Taxes (in US$) in Dominican Republic and Taxes (in US$) in Kazakhstan?
Provide a succinct answer. -2.63e+1. In the year 1995, what is the difference between the Taxes (in US$) in Dominican Republic and Taxes (in US$) in Peru?
Make the answer very short. 6.02e+09. In the year 1995, what is the difference between the Taxes (in US$) of Dominican Republic and Taxes (in US$) of Tanzania?
Make the answer very short. -2.06e+11. In the year 1995, what is the difference between the Taxes (in US$) in Kazakhstan and Taxes (in US$) in Peru?
Make the answer very short. 3.23e+1. In the year 1995, what is the difference between the Taxes (in US$) of Kazakhstan and Taxes (in US$) of Tanzania?
Provide a succinct answer. -1.80e+11. In the year 1995, what is the difference between the Taxes (in US$) of Peru and Taxes (in US$) of Tanzania?
Provide a short and direct response. -2.12e+11. In the year 1996, what is the difference between the Taxes (in US$) in Dominican Republic and Taxes (in US$) in Kazakhstan?
Your answer should be compact. -5.24e+1. In the year 1996, what is the difference between the Taxes (in US$) in Dominican Republic and Taxes (in US$) in Peru?
Your answer should be compact. 4.95e+09. In the year 1996, what is the difference between the Taxes (in US$) in Dominican Republic and Taxes (in US$) in Tanzania?
Offer a very short reply. -2.97e+11. In the year 1996, what is the difference between the Taxes (in US$) in Kazakhstan and Taxes (in US$) in Peru?
Offer a very short reply. 5.74e+1. In the year 1996, what is the difference between the Taxes (in US$) in Kazakhstan and Taxes (in US$) in Tanzania?
Offer a very short reply. -2.45e+11. In the year 1996, what is the difference between the Taxes (in US$) of Peru and Taxes (in US$) of Tanzania?
Keep it short and to the point. -3.02e+11. In the year 1997, what is the difference between the Taxes (in US$) of Dominican Republic and Taxes (in US$) of Kazakhstan?
Ensure brevity in your answer.  -5.36e+1. In the year 1997, what is the difference between the Taxes (in US$) in Dominican Republic and Taxes (in US$) in Peru?
Your answer should be very brief. 8.33e+09. In the year 1997, what is the difference between the Taxes (in US$) of Dominican Republic and Taxes (in US$) of Tanzania?
Keep it short and to the point. -3.99e+11. In the year 1997, what is the difference between the Taxes (in US$) of Kazakhstan and Taxes (in US$) of Peru?
Your answer should be very brief. 6.19e+1. In the year 1997, what is the difference between the Taxes (in US$) in Kazakhstan and Taxes (in US$) in Tanzania?
Provide a short and direct response. -3.45e+11. In the year 1997, what is the difference between the Taxes (in US$) in Peru and Taxes (in US$) in Tanzania?
Give a very brief answer. -4.07e+11. In the year 1998, what is the difference between the Taxes (in US$) of Dominican Republic and Taxes (in US$) of Kazakhstan?
Provide a succinct answer. -7.48e+1. In the year 1998, what is the difference between the Taxes (in US$) of Dominican Republic and Taxes (in US$) of Peru?
Offer a very short reply. 1.30e+1. In the year 1998, what is the difference between the Taxes (in US$) in Dominican Republic and Taxes (in US$) in Tanzania?
Your answer should be very brief. -3.91e+11. In the year 1998, what is the difference between the Taxes (in US$) of Kazakhstan and Taxes (in US$) of Peru?
Make the answer very short. 8.79e+1. In the year 1998, what is the difference between the Taxes (in US$) of Kazakhstan and Taxes (in US$) of Tanzania?
Keep it short and to the point. -3.17e+11. In the year 1998, what is the difference between the Taxes (in US$) of Peru and Taxes (in US$) of Tanzania?
Offer a very short reply. -4.04e+11. In the year 1999, what is the difference between the Taxes (in US$) of Dominican Republic and Taxes (in US$) of Kazakhstan?
Provide a short and direct response. -8.27e+1. In the year 1999, what is the difference between the Taxes (in US$) in Dominican Republic and Taxes (in US$) in Peru?
Keep it short and to the point. 1.51e+1. In the year 1999, what is the difference between the Taxes (in US$) of Dominican Republic and Taxes (in US$) of Tanzania?
Give a very brief answer. -3.98e+11. In the year 1999, what is the difference between the Taxes (in US$) in Kazakhstan and Taxes (in US$) in Peru?
Offer a very short reply. 9.78e+1. In the year 1999, what is the difference between the Taxes (in US$) of Kazakhstan and Taxes (in US$) of Tanzania?
Give a very brief answer. -3.15e+11. In the year 1999, what is the difference between the Taxes (in US$) in Peru and Taxes (in US$) in Tanzania?
Offer a very short reply. -4.13e+11. In the year 2000, what is the difference between the Taxes (in US$) of Dominican Republic and Taxes (in US$) of Kazakhstan?
Your answer should be very brief. -1.33e+11. In the year 2000, what is the difference between the Taxes (in US$) of Dominican Republic and Taxes (in US$) of Peru?
Your answer should be very brief. 2.31e+1. In the year 2000, what is the difference between the Taxes (in US$) of Dominican Republic and Taxes (in US$) of Tanzania?
Offer a very short reply. -4.90e+11. In the year 2000, what is the difference between the Taxes (in US$) in Kazakhstan and Taxes (in US$) in Peru?
Give a very brief answer. 1.56e+11. In the year 2000, what is the difference between the Taxes (in US$) of Kazakhstan and Taxes (in US$) of Tanzania?
Ensure brevity in your answer.  -3.56e+11. In the year 2000, what is the difference between the Taxes (in US$) of Peru and Taxes (in US$) of Tanzania?
Your answer should be very brief. -5.13e+11. In the year 2001, what is the difference between the Taxes (in US$) in Dominican Republic and Taxes (in US$) in Kazakhstan?
Your response must be concise. -1.82e+11. In the year 2001, what is the difference between the Taxes (in US$) in Dominican Republic and Taxes (in US$) in Peru?
Ensure brevity in your answer.  2.64e+1. In the year 2001, what is the difference between the Taxes (in US$) in Dominican Republic and Taxes (in US$) in Tanzania?
Your response must be concise. -5.70e+11. In the year 2001, what is the difference between the Taxes (in US$) in Kazakhstan and Taxes (in US$) in Peru?
Offer a very short reply. 2.09e+11. In the year 2001, what is the difference between the Taxes (in US$) of Kazakhstan and Taxes (in US$) of Tanzania?
Make the answer very short. -3.87e+11. In the year 2001, what is the difference between the Taxes (in US$) of Peru and Taxes (in US$) of Tanzania?
Make the answer very short. -5.96e+11. In the year 2002, what is the difference between the Taxes (in US$) in Dominican Republic and Taxes (in US$) in Kazakhstan?
Offer a very short reply. -2.29e+11. In the year 2002, what is the difference between the Taxes (in US$) in Dominican Republic and Taxes (in US$) in Peru?
Offer a terse response. 2.57e+1. In the year 2002, what is the difference between the Taxes (in US$) in Dominican Republic and Taxes (in US$) in Tanzania?
Your response must be concise. -6.62e+11. In the year 2002, what is the difference between the Taxes (in US$) in Kazakhstan and Taxes (in US$) in Peru?
Offer a terse response. 2.55e+11. In the year 2002, what is the difference between the Taxes (in US$) in Kazakhstan and Taxes (in US$) in Tanzania?
Your response must be concise. -4.33e+11. In the year 2002, what is the difference between the Taxes (in US$) in Peru and Taxes (in US$) in Tanzania?
Provide a succinct answer. -6.88e+11. What is the ratio of the Taxes (in US$) in Dominican Republic in 1995 to that in 1996?
Keep it short and to the point. 1. What is the ratio of the Taxes (in US$) of Kazakhstan in 1995 to that in 1996?
Make the answer very short. 0.63. What is the ratio of the Taxes (in US$) in Peru in 1995 to that in 1996?
Your answer should be very brief. 0.92. What is the ratio of the Taxes (in US$) in Tanzania in 1995 to that in 1996?
Offer a terse response. 0.71. What is the ratio of the Taxes (in US$) of Dominican Republic in 1995 to that in 1997?
Ensure brevity in your answer.  0.77. What is the ratio of the Taxes (in US$) of Kazakhstan in 1995 to that in 1997?
Provide a short and direct response. 0.58. What is the ratio of the Taxes (in US$) in Peru in 1995 to that in 1997?
Your answer should be very brief. 0.8. What is the ratio of the Taxes (in US$) of Tanzania in 1995 to that in 1997?
Ensure brevity in your answer.  0.53. What is the ratio of the Taxes (in US$) in Dominican Republic in 1995 to that in 1998?
Make the answer very short. 0.62. What is the ratio of the Taxes (in US$) of Kazakhstan in 1995 to that in 1998?
Ensure brevity in your answer.  0.43. What is the ratio of the Taxes (in US$) of Peru in 1995 to that in 1998?
Your response must be concise. 0.76. What is the ratio of the Taxes (in US$) in Tanzania in 1995 to that in 1998?
Offer a terse response. 0.53. What is the ratio of the Taxes (in US$) of Dominican Republic in 1995 to that in 1999?
Keep it short and to the point. 0.58. What is the ratio of the Taxes (in US$) of Kazakhstan in 1995 to that in 1999?
Your answer should be compact. 0.39. What is the ratio of the Taxes (in US$) of Peru in 1995 to that in 1999?
Give a very brief answer. 0.76. What is the ratio of the Taxes (in US$) of Tanzania in 1995 to that in 1999?
Give a very brief answer. 0.52. What is the ratio of the Taxes (in US$) of Dominican Republic in 1995 to that in 2000?
Provide a short and direct response. 0.46. What is the ratio of the Taxes (in US$) in Kazakhstan in 1995 to that in 2000?
Give a very brief answer. 0.26. What is the ratio of the Taxes (in US$) of Peru in 1995 to that in 2000?
Provide a short and direct response. 0.74. What is the ratio of the Taxes (in US$) of Tanzania in 1995 to that in 2000?
Offer a terse response. 0.42. What is the ratio of the Taxes (in US$) of Dominican Republic in 1995 to that in 2001?
Your answer should be compact. 0.43. What is the ratio of the Taxes (in US$) of Kazakhstan in 1995 to that in 2001?
Offer a terse response. 0.2. What is the ratio of the Taxes (in US$) in Peru in 1995 to that in 2001?
Offer a terse response. 0.75. What is the ratio of the Taxes (in US$) of Tanzania in 1995 to that in 2001?
Your response must be concise. 0.37. What is the ratio of the Taxes (in US$) in Dominican Republic in 1995 to that in 2002?
Provide a short and direct response. 0.42. What is the ratio of the Taxes (in US$) of Kazakhstan in 1995 to that in 2002?
Your answer should be compact. 0.16. What is the ratio of the Taxes (in US$) in Peru in 1995 to that in 2002?
Your answer should be very brief. 0.71. What is the ratio of the Taxes (in US$) of Tanzania in 1995 to that in 2002?
Provide a short and direct response. 0.32. What is the ratio of the Taxes (in US$) of Dominican Republic in 1996 to that in 1997?
Your answer should be very brief. 0.77. What is the ratio of the Taxes (in US$) of Kazakhstan in 1996 to that in 1997?
Provide a succinct answer. 0.92. What is the ratio of the Taxes (in US$) in Peru in 1996 to that in 1997?
Your response must be concise. 0.87. What is the ratio of the Taxes (in US$) in Tanzania in 1996 to that in 1997?
Give a very brief answer. 0.75. What is the ratio of the Taxes (in US$) in Dominican Republic in 1996 to that in 1998?
Your answer should be compact. 0.62. What is the ratio of the Taxes (in US$) in Kazakhstan in 1996 to that in 1998?
Ensure brevity in your answer.  0.68. What is the ratio of the Taxes (in US$) in Peru in 1996 to that in 1998?
Keep it short and to the point. 0.82. What is the ratio of the Taxes (in US$) in Tanzania in 1996 to that in 1998?
Offer a very short reply. 0.75. What is the ratio of the Taxes (in US$) of Dominican Republic in 1996 to that in 1999?
Ensure brevity in your answer.  0.58. What is the ratio of the Taxes (in US$) in Kazakhstan in 1996 to that in 1999?
Make the answer very short. 0.62. What is the ratio of the Taxes (in US$) in Peru in 1996 to that in 1999?
Make the answer very short. 0.83. What is the ratio of the Taxes (in US$) in Tanzania in 1996 to that in 1999?
Offer a very short reply. 0.74. What is the ratio of the Taxes (in US$) in Dominican Republic in 1996 to that in 2000?
Provide a succinct answer. 0.46. What is the ratio of the Taxes (in US$) in Kazakhstan in 1996 to that in 2000?
Provide a succinct answer. 0.41. What is the ratio of the Taxes (in US$) in Peru in 1996 to that in 2000?
Provide a succinct answer. 0.8. What is the ratio of the Taxes (in US$) in Tanzania in 1996 to that in 2000?
Your answer should be very brief. 0.6. What is the ratio of the Taxes (in US$) in Dominican Republic in 1996 to that in 2001?
Your answer should be compact. 0.42. What is the ratio of the Taxes (in US$) in Kazakhstan in 1996 to that in 2001?
Keep it short and to the point. 0.31. What is the ratio of the Taxes (in US$) of Peru in 1996 to that in 2001?
Keep it short and to the point. 0.82. What is the ratio of the Taxes (in US$) of Tanzania in 1996 to that in 2001?
Your response must be concise. 0.51. What is the ratio of the Taxes (in US$) in Dominican Republic in 1996 to that in 2002?
Keep it short and to the point. 0.42. What is the ratio of the Taxes (in US$) of Kazakhstan in 1996 to that in 2002?
Offer a terse response. 0.26. What is the ratio of the Taxes (in US$) of Peru in 1996 to that in 2002?
Keep it short and to the point. 0.77. What is the ratio of the Taxes (in US$) in Tanzania in 1996 to that in 2002?
Keep it short and to the point. 0.45. What is the ratio of the Taxes (in US$) of Dominican Republic in 1997 to that in 1998?
Keep it short and to the point. 0.81. What is the ratio of the Taxes (in US$) of Kazakhstan in 1997 to that in 1998?
Offer a very short reply. 0.74. What is the ratio of the Taxes (in US$) of Peru in 1997 to that in 1998?
Keep it short and to the point. 0.95. What is the ratio of the Taxes (in US$) in Dominican Republic in 1997 to that in 1999?
Offer a terse response. 0.76. What is the ratio of the Taxes (in US$) of Kazakhstan in 1997 to that in 1999?
Your response must be concise. 0.68. What is the ratio of the Taxes (in US$) of Peru in 1997 to that in 1999?
Make the answer very short. 0.95. What is the ratio of the Taxes (in US$) in Tanzania in 1997 to that in 1999?
Make the answer very short. 0.98. What is the ratio of the Taxes (in US$) in Dominican Republic in 1997 to that in 2000?
Give a very brief answer. 0.59. What is the ratio of the Taxes (in US$) in Kazakhstan in 1997 to that in 2000?
Offer a very short reply. 0.45. What is the ratio of the Taxes (in US$) of Peru in 1997 to that in 2000?
Ensure brevity in your answer.  0.92. What is the ratio of the Taxes (in US$) in Tanzania in 1997 to that in 2000?
Make the answer very short. 0.8. What is the ratio of the Taxes (in US$) of Dominican Republic in 1997 to that in 2001?
Ensure brevity in your answer.  0.55. What is the ratio of the Taxes (in US$) of Kazakhstan in 1997 to that in 2001?
Offer a very short reply. 0.34. What is the ratio of the Taxes (in US$) of Peru in 1997 to that in 2001?
Your response must be concise. 0.94. What is the ratio of the Taxes (in US$) in Tanzania in 1997 to that in 2001?
Provide a succinct answer. 0.69. What is the ratio of the Taxes (in US$) in Dominican Republic in 1997 to that in 2002?
Provide a short and direct response. 0.55. What is the ratio of the Taxes (in US$) of Kazakhstan in 1997 to that in 2002?
Keep it short and to the point. 0.28. What is the ratio of the Taxes (in US$) in Peru in 1997 to that in 2002?
Make the answer very short. 0.89. What is the ratio of the Taxes (in US$) of Tanzania in 1997 to that in 2002?
Make the answer very short. 0.6. What is the ratio of the Taxes (in US$) of Dominican Republic in 1998 to that in 1999?
Offer a very short reply. 0.94. What is the ratio of the Taxes (in US$) in Kazakhstan in 1998 to that in 1999?
Provide a short and direct response. 0.91. What is the ratio of the Taxes (in US$) of Peru in 1998 to that in 1999?
Offer a terse response. 1.01. What is the ratio of the Taxes (in US$) of Tanzania in 1998 to that in 1999?
Make the answer very short. 0.98. What is the ratio of the Taxes (in US$) of Dominican Republic in 1998 to that in 2000?
Offer a terse response. 0.73. What is the ratio of the Taxes (in US$) of Kazakhstan in 1998 to that in 2000?
Your answer should be very brief. 0.6. What is the ratio of the Taxes (in US$) of Peru in 1998 to that in 2000?
Provide a short and direct response. 0.97. What is the ratio of the Taxes (in US$) in Tanzania in 1998 to that in 2000?
Provide a succinct answer. 0.79. What is the ratio of the Taxes (in US$) in Dominican Republic in 1998 to that in 2001?
Provide a succinct answer. 0.68. What is the ratio of the Taxes (in US$) of Kazakhstan in 1998 to that in 2001?
Provide a succinct answer. 0.46. What is the ratio of the Taxes (in US$) in Tanzania in 1998 to that in 2001?
Make the answer very short. 0.69. What is the ratio of the Taxes (in US$) in Dominican Republic in 1998 to that in 2002?
Your response must be concise. 0.68. What is the ratio of the Taxes (in US$) in Kazakhstan in 1998 to that in 2002?
Provide a succinct answer. 0.38. What is the ratio of the Taxes (in US$) of Peru in 1998 to that in 2002?
Offer a very short reply. 0.94. What is the ratio of the Taxes (in US$) in Tanzania in 1998 to that in 2002?
Offer a terse response. 0.6. What is the ratio of the Taxes (in US$) in Dominican Republic in 1999 to that in 2000?
Your response must be concise. 0.78. What is the ratio of the Taxes (in US$) in Kazakhstan in 1999 to that in 2000?
Offer a terse response. 0.66. What is the ratio of the Taxes (in US$) of Peru in 1999 to that in 2000?
Offer a very short reply. 0.97. What is the ratio of the Taxes (in US$) in Tanzania in 1999 to that in 2000?
Give a very brief answer. 0.81. What is the ratio of the Taxes (in US$) in Dominican Republic in 1999 to that in 2001?
Keep it short and to the point. 0.73. What is the ratio of the Taxes (in US$) in Kazakhstan in 1999 to that in 2001?
Keep it short and to the point. 0.51. What is the ratio of the Taxes (in US$) in Peru in 1999 to that in 2001?
Provide a short and direct response. 0.99. What is the ratio of the Taxes (in US$) in Tanzania in 1999 to that in 2001?
Ensure brevity in your answer.  0.7. What is the ratio of the Taxes (in US$) in Dominican Republic in 1999 to that in 2002?
Make the answer very short. 0.72. What is the ratio of the Taxes (in US$) of Kazakhstan in 1999 to that in 2002?
Your answer should be very brief. 0.42. What is the ratio of the Taxes (in US$) of Peru in 1999 to that in 2002?
Your answer should be compact. 0.93. What is the ratio of the Taxes (in US$) in Tanzania in 1999 to that in 2002?
Your answer should be compact. 0.61. What is the ratio of the Taxes (in US$) in Dominican Republic in 2000 to that in 2001?
Ensure brevity in your answer.  0.93. What is the ratio of the Taxes (in US$) of Kazakhstan in 2000 to that in 2001?
Provide a short and direct response. 0.77. What is the ratio of the Taxes (in US$) in Peru in 2000 to that in 2001?
Give a very brief answer. 1.02. What is the ratio of the Taxes (in US$) in Tanzania in 2000 to that in 2001?
Your response must be concise. 0.86. What is the ratio of the Taxes (in US$) of Dominican Republic in 2000 to that in 2002?
Offer a very short reply. 0.93. What is the ratio of the Taxes (in US$) of Kazakhstan in 2000 to that in 2002?
Offer a very short reply. 0.64. What is the ratio of the Taxes (in US$) in Peru in 2000 to that in 2002?
Give a very brief answer. 0.96. What is the ratio of the Taxes (in US$) of Tanzania in 2000 to that in 2002?
Make the answer very short. 0.75. What is the ratio of the Taxes (in US$) in Kazakhstan in 2001 to that in 2002?
Offer a terse response. 0.83. What is the ratio of the Taxes (in US$) in Peru in 2001 to that in 2002?
Ensure brevity in your answer.  0.94. What is the ratio of the Taxes (in US$) in Tanzania in 2001 to that in 2002?
Make the answer very short. 0.87. What is the difference between the highest and the second highest Taxes (in US$) of Dominican Republic?
Your response must be concise. 2.54e+08. What is the difference between the highest and the second highest Taxes (in US$) in Kazakhstan?
Keep it short and to the point. 4.72e+1. What is the difference between the highest and the second highest Taxes (in US$) of Peru?
Keep it short and to the point. 6.46e+08. What is the difference between the highest and the second highest Taxes (in US$) in Tanzania?
Provide a succinct answer. 9.26e+1. What is the difference between the highest and the lowest Taxes (in US$) in Dominican Republic?
Offer a very short reply. 2.46e+1. What is the difference between the highest and the lowest Taxes (in US$) in Kazakhstan?
Keep it short and to the point. 2.27e+11. What is the difference between the highest and the lowest Taxes (in US$) in Peru?
Keep it short and to the point. 4.89e+09. What is the difference between the highest and the lowest Taxes (in US$) of Tanzania?
Provide a succinct answer. 4.81e+11. 